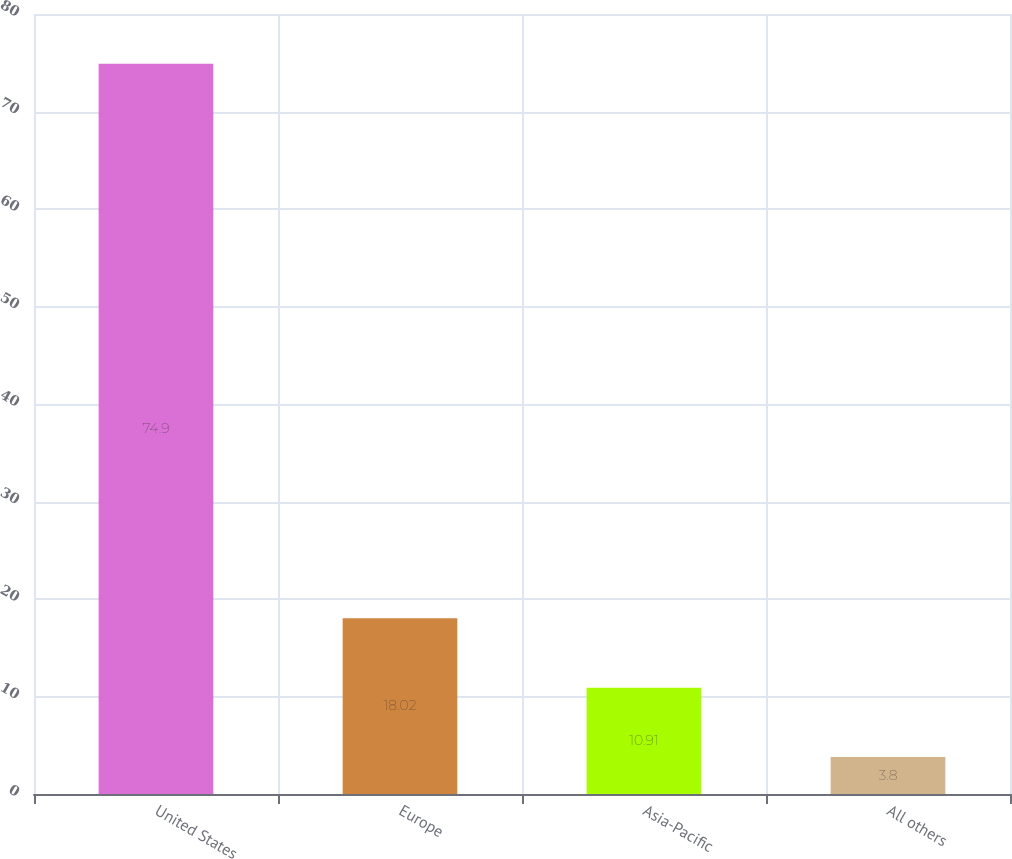Convert chart. <chart><loc_0><loc_0><loc_500><loc_500><bar_chart><fcel>United States<fcel>Europe<fcel>Asia-Pacific<fcel>All others<nl><fcel>74.9<fcel>18.02<fcel>10.91<fcel>3.8<nl></chart> 